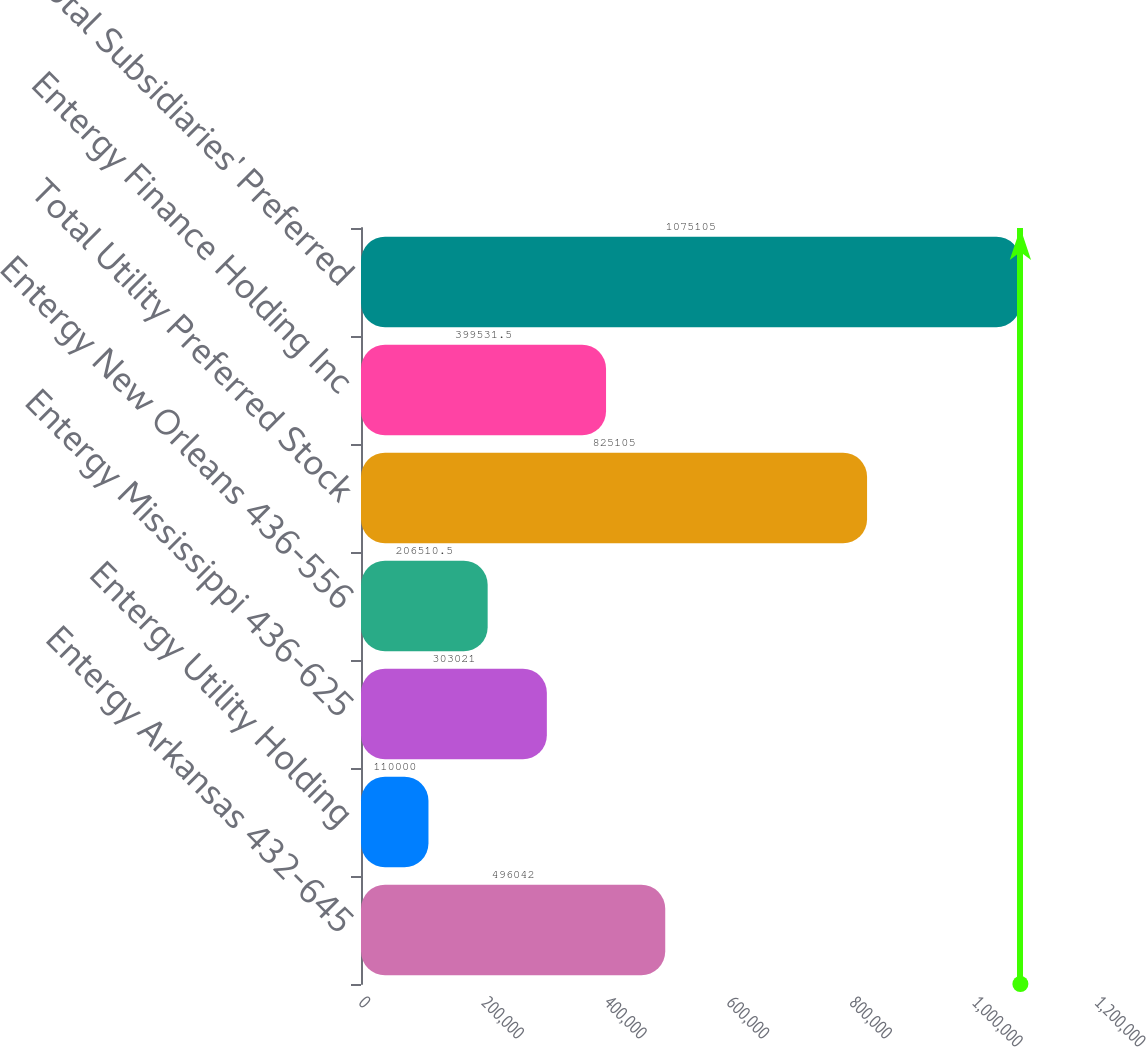Convert chart. <chart><loc_0><loc_0><loc_500><loc_500><bar_chart><fcel>Entergy Arkansas 432-645<fcel>Entergy Utility Holding<fcel>Entergy Mississippi 436-625<fcel>Entergy New Orleans 436-556<fcel>Total Utility Preferred Stock<fcel>Entergy Finance Holding Inc<fcel>Total Subsidiaries' Preferred<nl><fcel>496042<fcel>110000<fcel>303021<fcel>206510<fcel>825105<fcel>399532<fcel>1.0751e+06<nl></chart> 